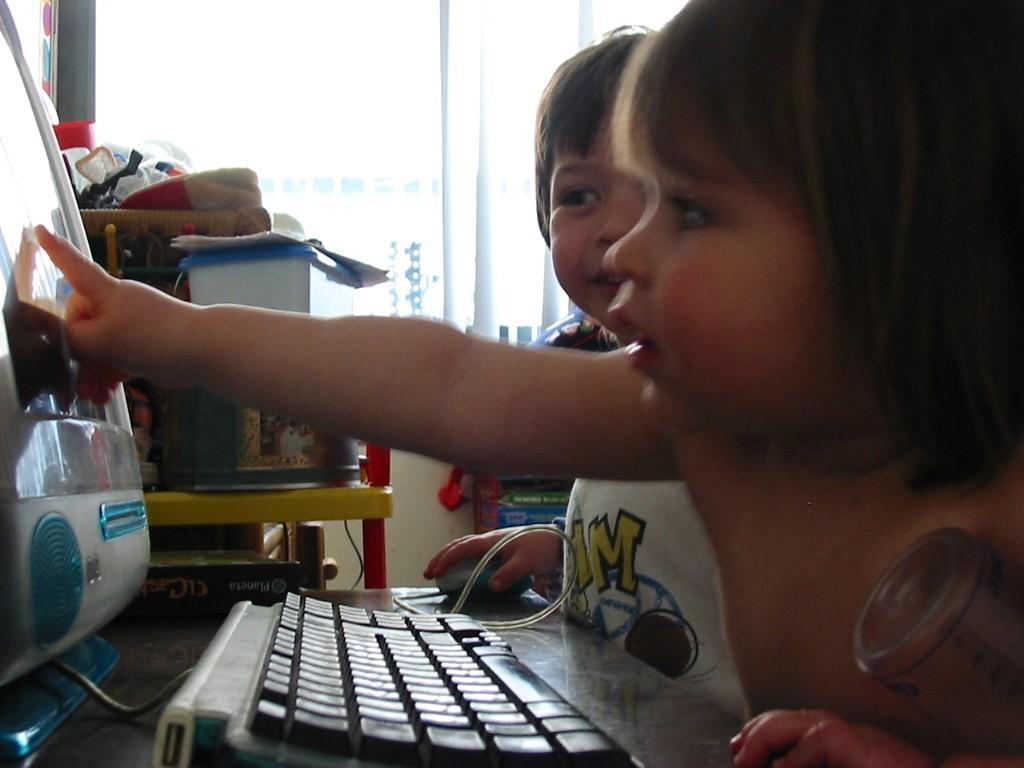How would you summarize this image in a sentence or two? In this image there are two children´s standing in front of the table, on which there is a monitor, keyboard and mouse, beside the table there are a few objects on the other table. In the background there is a window. 